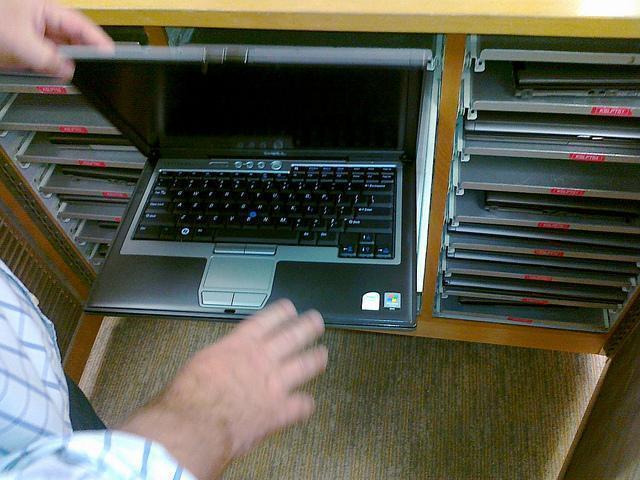What word is associated with the item the person is touching?
Select the accurate answer and provide justification: `Answer: choice
Rationale: srationale.`
Options: Space bar, orange, puppy, baby. Answer: space bar.
Rationale: The word is the space bar. 